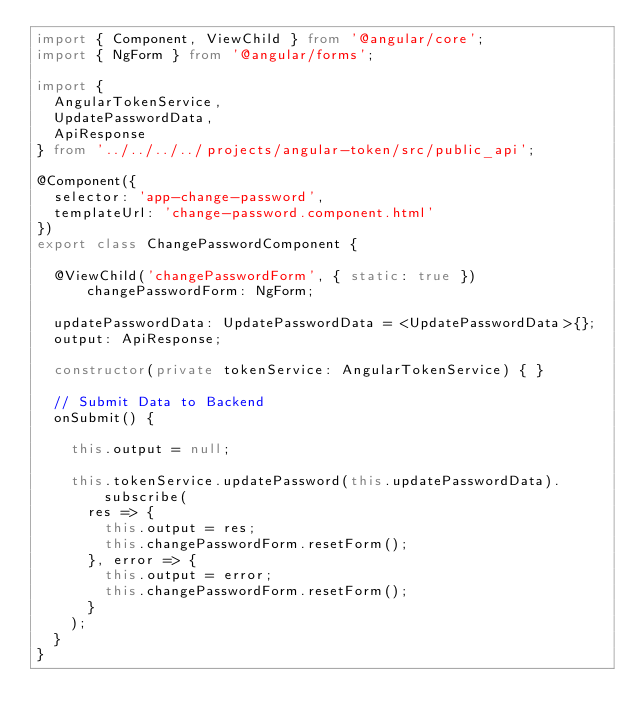Convert code to text. <code><loc_0><loc_0><loc_500><loc_500><_TypeScript_>import { Component, ViewChild } from '@angular/core';
import { NgForm } from '@angular/forms';

import {
  AngularTokenService,
  UpdatePasswordData,
  ApiResponse
} from '../../../../projects/angular-token/src/public_api';

@Component({
  selector: 'app-change-password',
  templateUrl: 'change-password.component.html'
})
export class ChangePasswordComponent {

  @ViewChild('changePasswordForm', { static: true }) changePasswordForm: NgForm;

  updatePasswordData: UpdatePasswordData = <UpdatePasswordData>{};
  output: ApiResponse;

  constructor(private tokenService: AngularTokenService) { }

  // Submit Data to Backend
  onSubmit() {

    this.output = null;

    this.tokenService.updatePassword(this.updatePasswordData).subscribe(
      res => {
        this.output = res;
        this.changePasswordForm.resetForm();
      }, error => {
        this.output = error;
        this.changePasswordForm.resetForm();
      }
    );
  }
}
</code> 